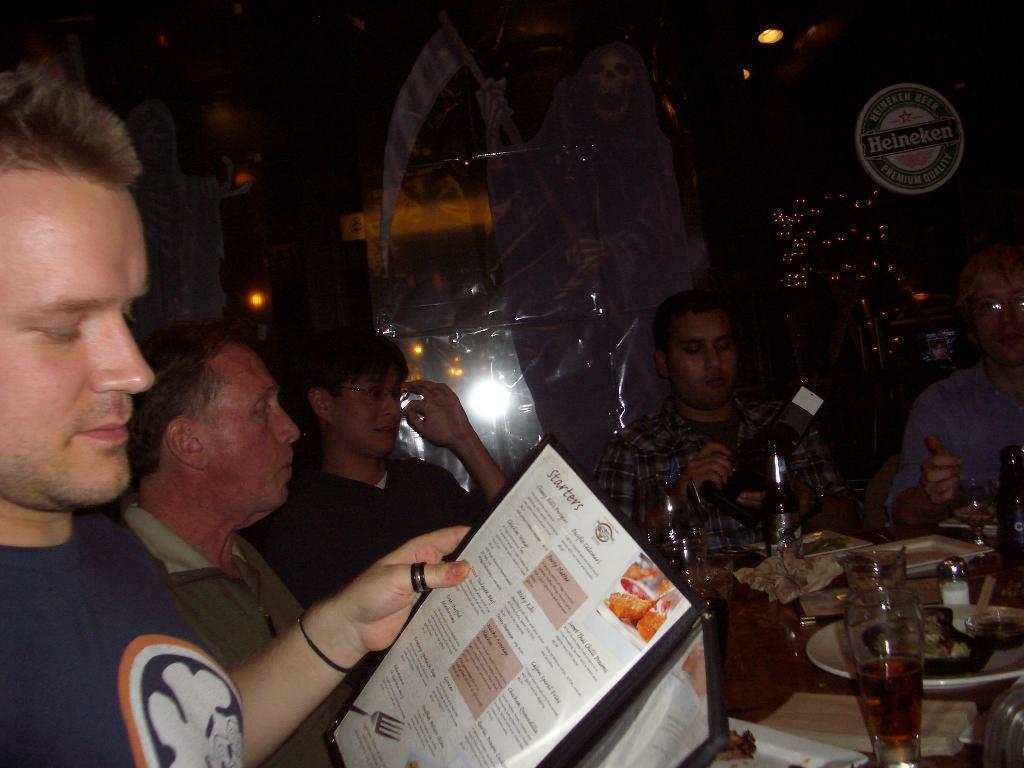Can you describe this image briefly? In the picture I can see people are sitting in front of a table among them the man in the front is holding a menu card in the hand. In the background I can see lights and some other objects. 